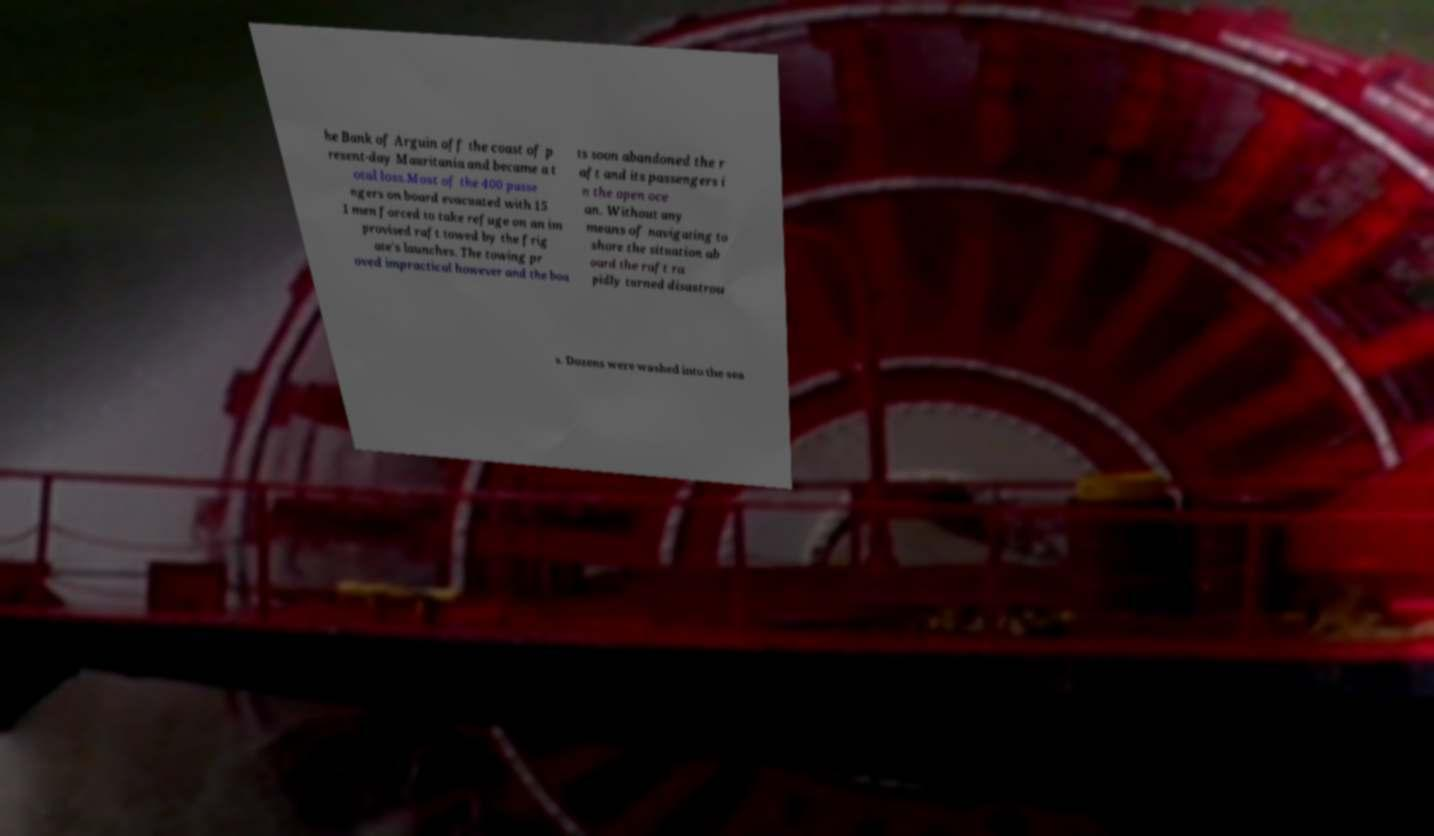There's text embedded in this image that I need extracted. Can you transcribe it verbatim? he Bank of Arguin off the coast of p resent-day Mauritania and became a t otal loss.Most of the 400 passe ngers on board evacuated with 15 1 men forced to take refuge on an im provised raft towed by the frig ate's launches. The towing pr oved impractical however and the boa ts soon abandoned the r aft and its passengers i n the open oce an. Without any means of navigating to shore the situation ab oard the raft ra pidly turned disastrou s. Dozens were washed into the sea 